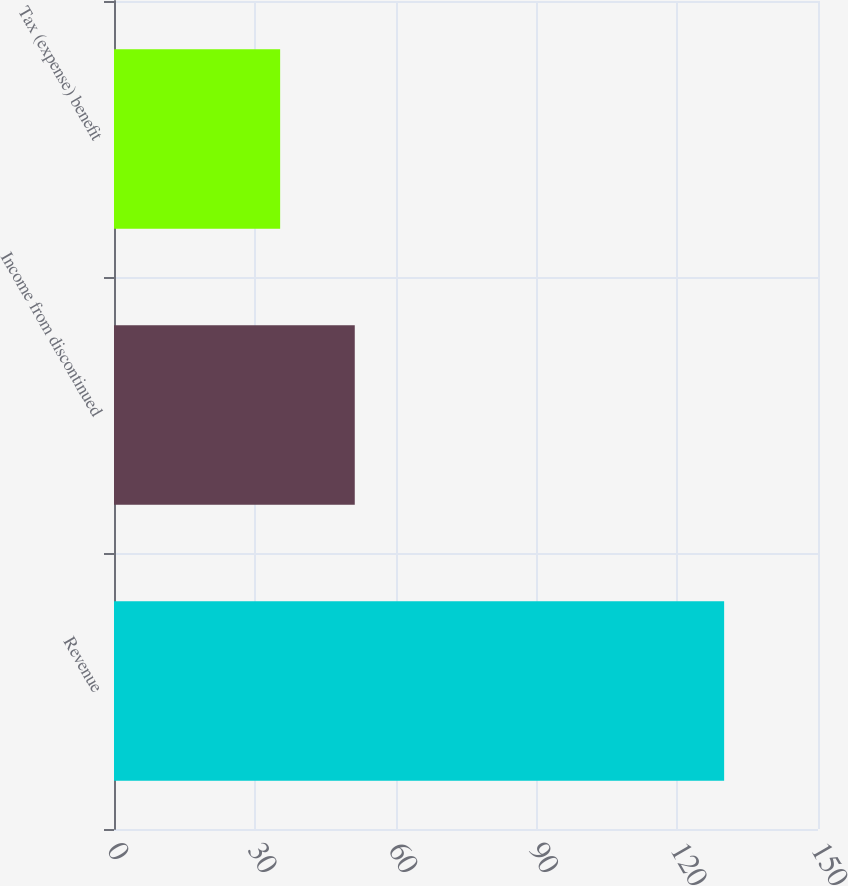Convert chart. <chart><loc_0><loc_0><loc_500><loc_500><bar_chart><fcel>Revenue<fcel>Income from discontinued<fcel>Tax (expense) benefit<nl><fcel>130<fcel>51.3<fcel>35.4<nl></chart> 